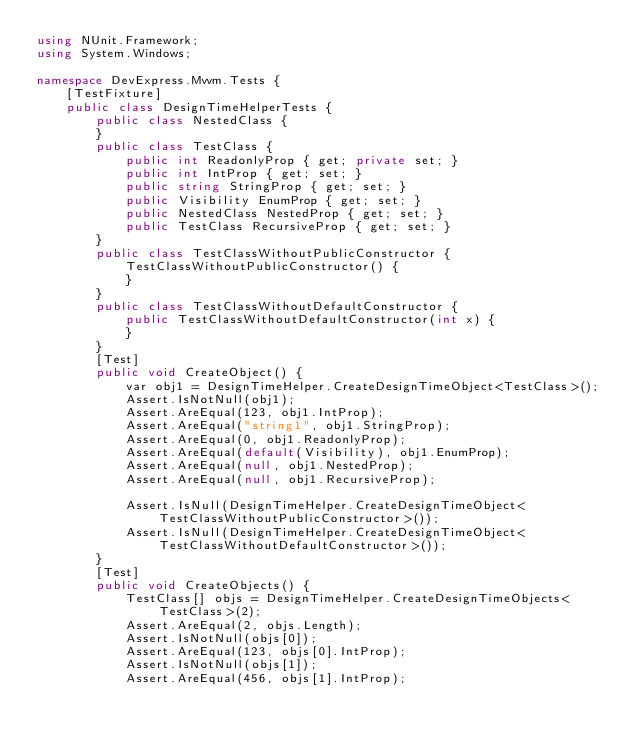<code> <loc_0><loc_0><loc_500><loc_500><_C#_>using NUnit.Framework;
using System.Windows;

namespace DevExpress.Mvvm.Tests {
    [TestFixture]
    public class DesignTimeHelperTests {
        public class NestedClass {
        }
        public class TestClass {
            public int ReadonlyProp { get; private set; }
            public int IntProp { get; set; }
            public string StringProp { get; set; }
            public Visibility EnumProp { get; set; }
            public NestedClass NestedProp { get; set; }
            public TestClass RecursiveProp { get; set; }
        }
        public class TestClassWithoutPublicConstructor {
            TestClassWithoutPublicConstructor() {
            }
        }
        public class TestClassWithoutDefaultConstructor {
            public TestClassWithoutDefaultConstructor(int x) {
            }
        }
        [Test]
        public void CreateObject() {
            var obj1 = DesignTimeHelper.CreateDesignTimeObject<TestClass>();
            Assert.IsNotNull(obj1);
            Assert.AreEqual(123, obj1.IntProp);
            Assert.AreEqual("string1", obj1.StringProp);
            Assert.AreEqual(0, obj1.ReadonlyProp);
            Assert.AreEqual(default(Visibility), obj1.EnumProp);
            Assert.AreEqual(null, obj1.NestedProp);
            Assert.AreEqual(null, obj1.RecursiveProp);

            Assert.IsNull(DesignTimeHelper.CreateDesignTimeObject<TestClassWithoutPublicConstructor>());
            Assert.IsNull(DesignTimeHelper.CreateDesignTimeObject<TestClassWithoutDefaultConstructor>());
        }
        [Test]
        public void CreateObjects() {
            TestClass[] objs = DesignTimeHelper.CreateDesignTimeObjects<TestClass>(2);
            Assert.AreEqual(2, objs.Length);
            Assert.IsNotNull(objs[0]);
            Assert.AreEqual(123, objs[0].IntProp);
            Assert.IsNotNull(objs[1]);
            Assert.AreEqual(456, objs[1].IntProp);
</code> 